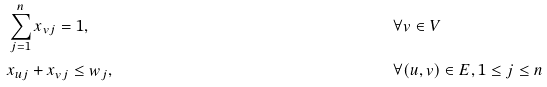<formula> <loc_0><loc_0><loc_500><loc_500>& \sum _ { j = 1 } ^ { n } x _ { v j } = 1 , & & \forall v \in V \\ & x _ { u j } + x _ { v j } \leq w _ { j } , & & \forall ( u , v ) \in E , 1 \leq j \leq n</formula> 